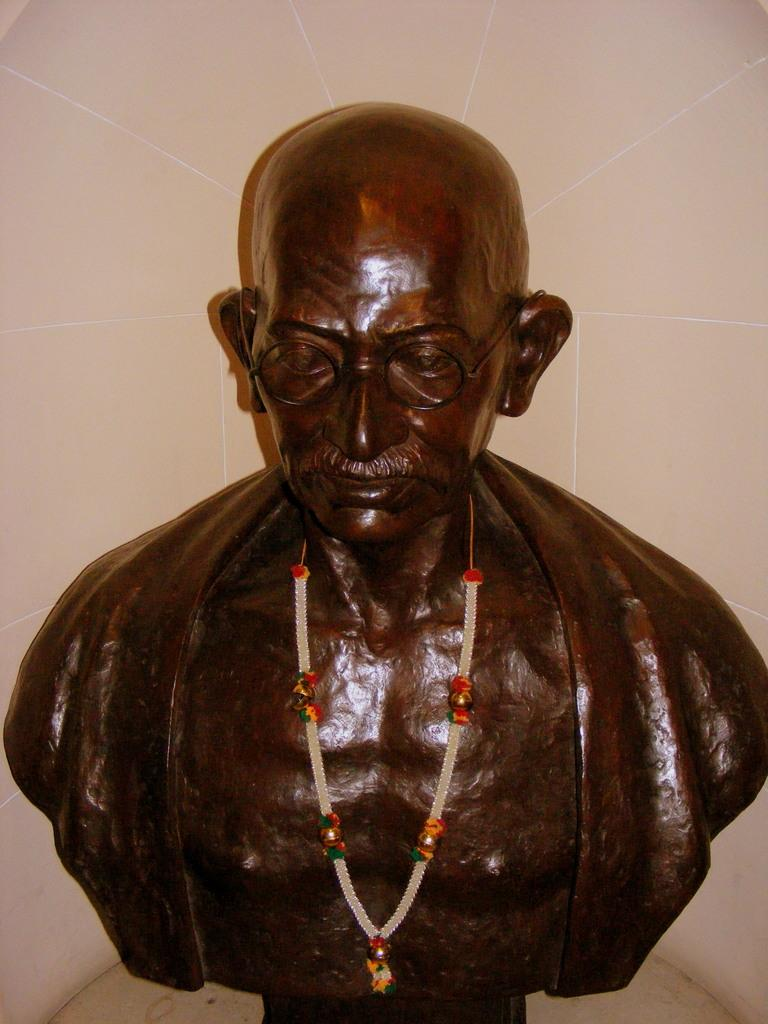What is the main subject of the image? There is a statue in the image. What is adorning the statue? The statue has a garland. What can be seen in the background of the image? There is a wall visible in the image. What type of dog can be seen playing with flowers near the statue in the image? There is no dog or flowers present in the image; it only features a statue with a garland and a wall in the background. 